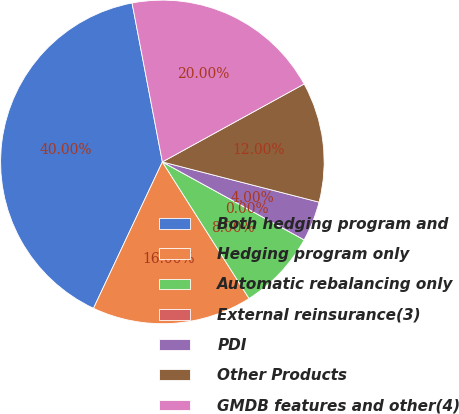<chart> <loc_0><loc_0><loc_500><loc_500><pie_chart><fcel>Both hedging program and<fcel>Hedging program only<fcel>Automatic rebalancing only<fcel>External reinsurance(3)<fcel>PDI<fcel>Other Products<fcel>GMDB features and other(4)<nl><fcel>40.0%<fcel>16.0%<fcel>8.0%<fcel>0.0%<fcel>4.0%<fcel>12.0%<fcel>20.0%<nl></chart> 